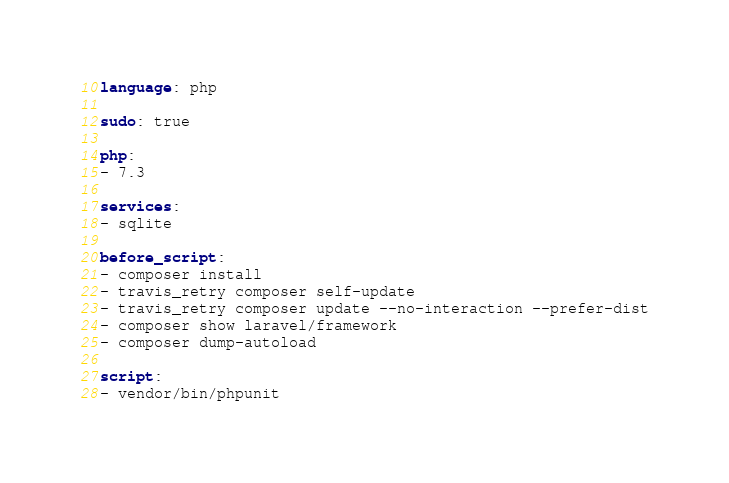Convert code to text. <code><loc_0><loc_0><loc_500><loc_500><_YAML_>language: php

sudo: true

php:
- 7.3

services:
- sqlite

before_script:
- composer install
- travis_retry composer self-update
- travis_retry composer update --no-interaction --prefer-dist
- composer show laravel/framework
- composer dump-autoload

script:
- vendor/bin/phpunit
</code> 